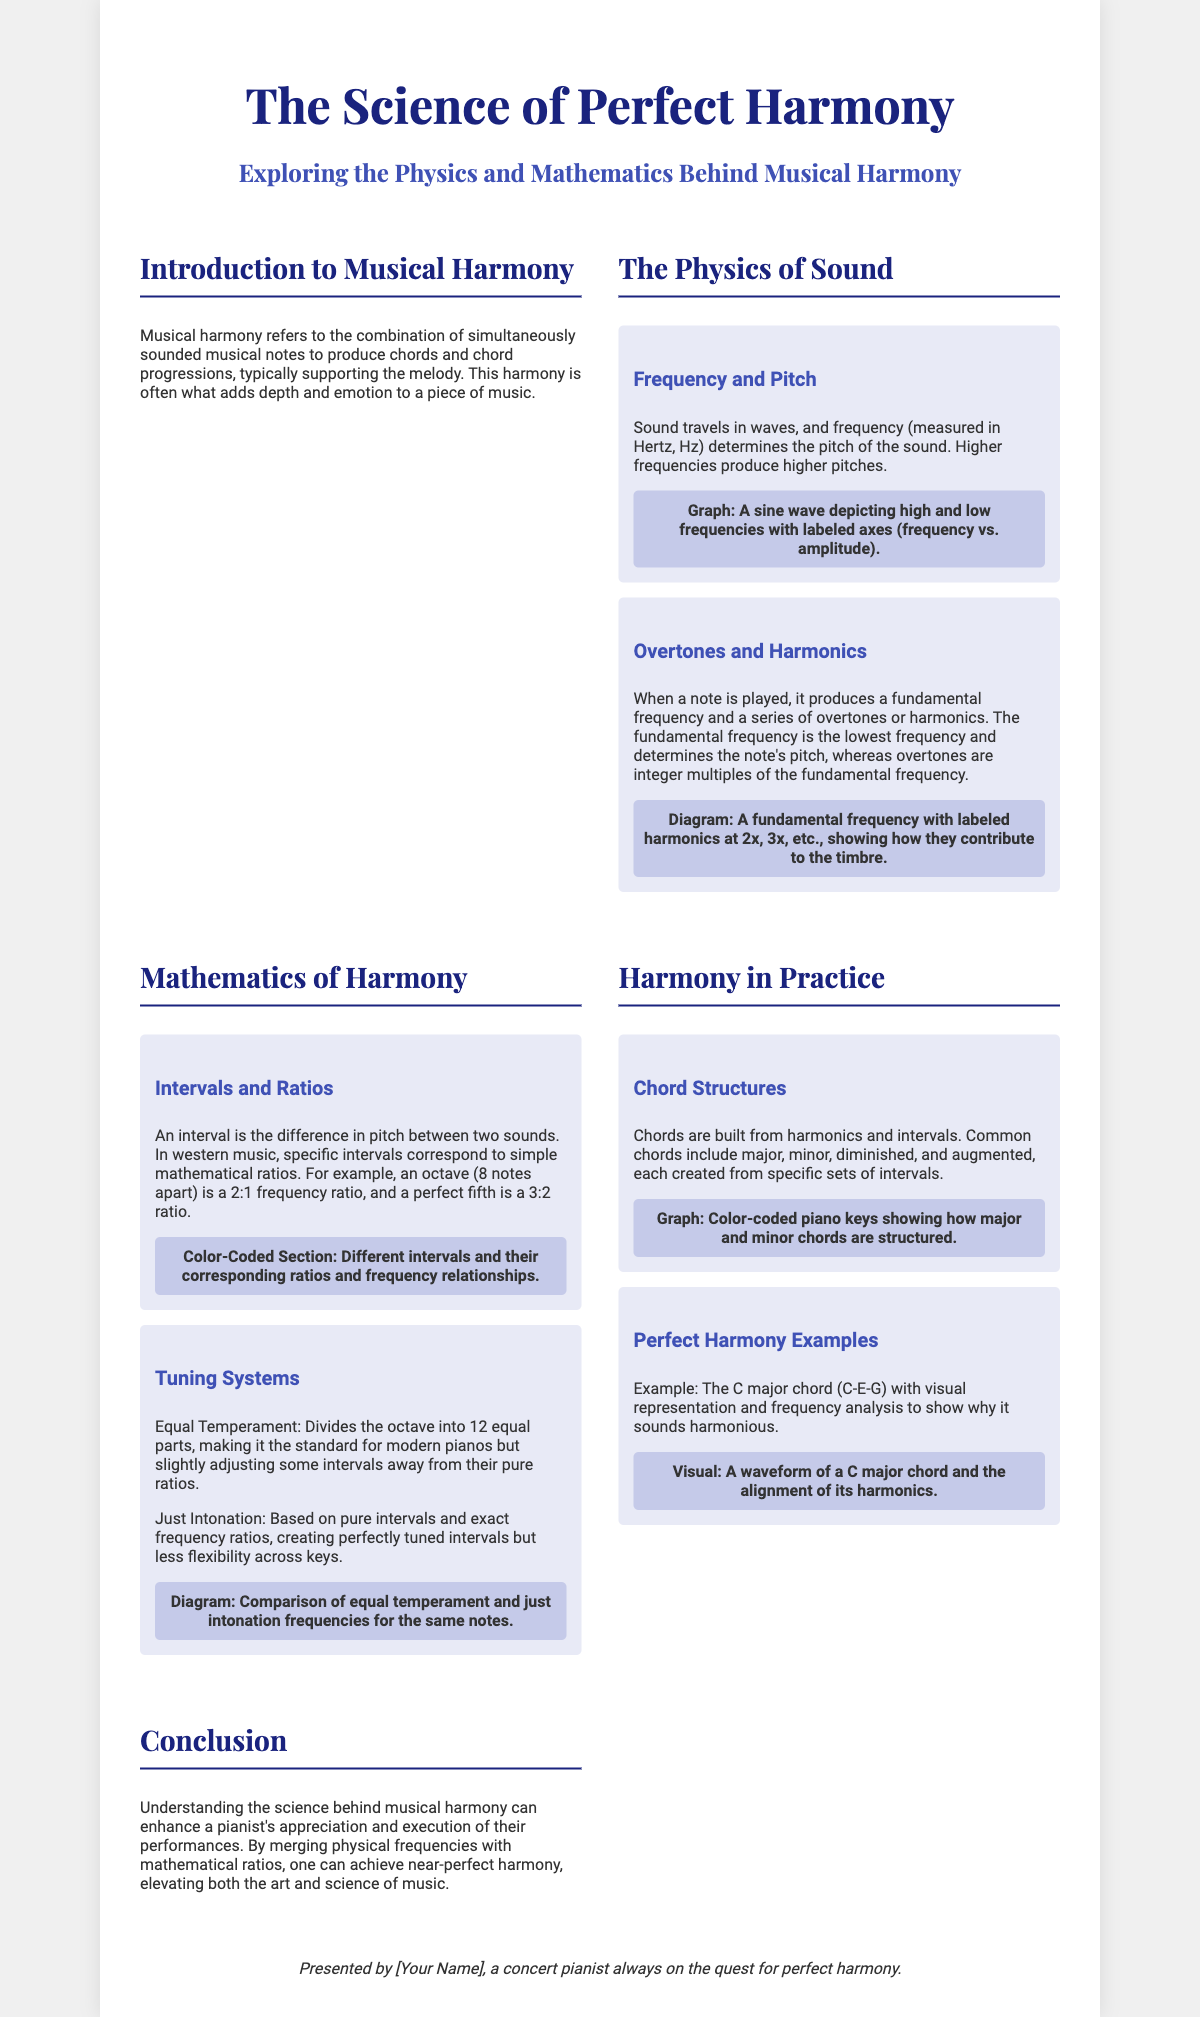What does musical harmony refer to? Musical harmony refers to the combination of simultaneously sounded musical notes to produce chords and chord progressions.
Answer: Combination of notes What is the unit of measurement for frequency? Frequency is measured in Hertz, Hz.
Answer: Hertz, Hz What ratio does a perfect fifth interval correspond to? A perfect fifth interval corresponds to a 3:2 ratio.
Answer: 3:2 What is the fundamental frequency? The fundamental frequency is the lowest frequency that determines the note's pitch.
Answer: Lowest frequency What are the two tuning systems mentioned? The two tuning systems mentioned are Equal Temperament and Just Intonation.
Answer: Equal Temperament and Just Intonation What chord example is given in the poster? The example given is the C major chord.
Answer: C major chord What does the diagram showing the sine wave depict? The diagram depicts high and low frequencies with labeled axes.
Answer: High and low frequencies How many sections are there in the poster? There are five sections in the poster.
Answer: Five sections What does understanding the science of harmony enhance for a pianist? Understanding the science enhances a pianist's appreciation and execution of their performances.
Answer: Appreciation and execution 